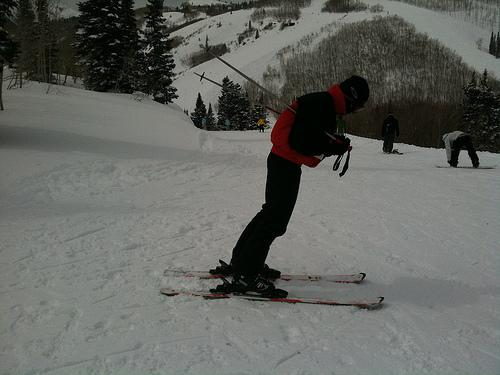Question: what is on the ground?
Choices:
A. Rocks.
B. Puddles.
C. Leaves.
D. Snow.
Answer with the letter. Answer: D Question: where is this picture taken?
Choices:
A. A ski slope.
B. Beach.
C. City.
D. On a farm.
Answer with the letter. Answer: A Question: what color is the man's jacket?
Choices:
A. Orange.
B. Blue.
C. Red.
D. Purple.
Answer with the letter. Answer: C 